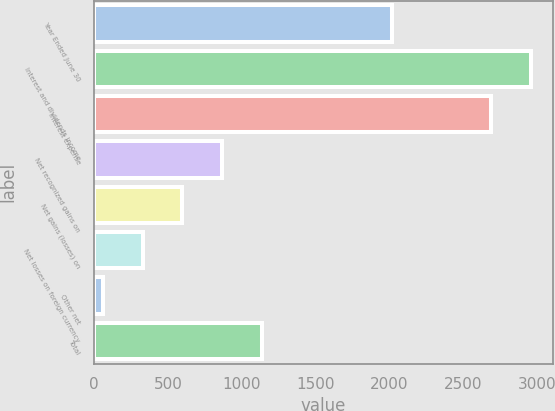<chart> <loc_0><loc_0><loc_500><loc_500><bar_chart><fcel>Year Ended June 30<fcel>Interest and dividends income<fcel>Interest expense<fcel>Net recognized gains on<fcel>Net gains (losses) on<fcel>Net losses on foreign currency<fcel>Other net<fcel>Total<nl><fcel>2019<fcel>2956.5<fcel>2686<fcel>868.5<fcel>598<fcel>327.5<fcel>57<fcel>1139<nl></chart> 